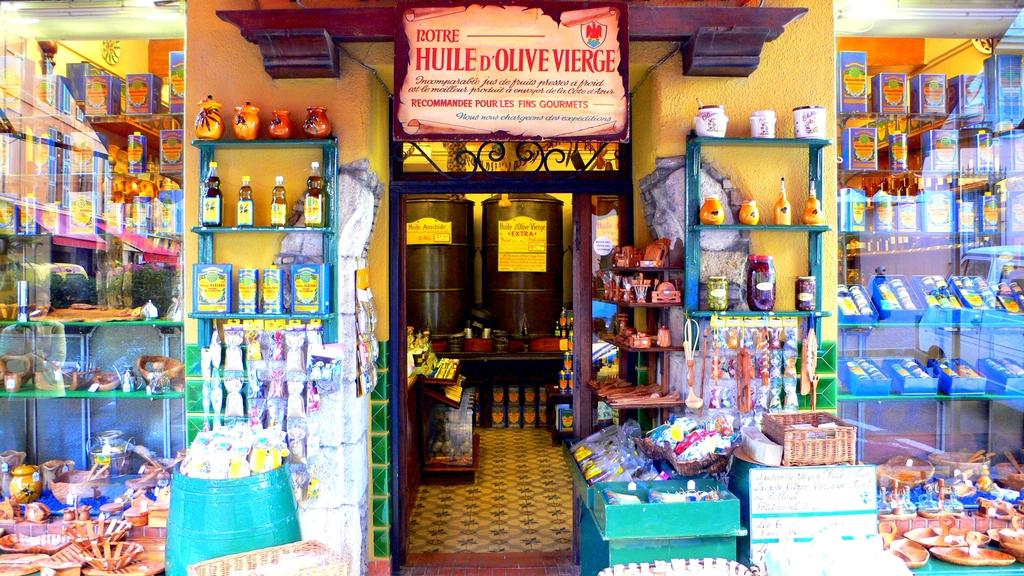<image>
Create a compact narrative representing the image presented. A store of many items and sign reading Rotre Huile D Olive above 